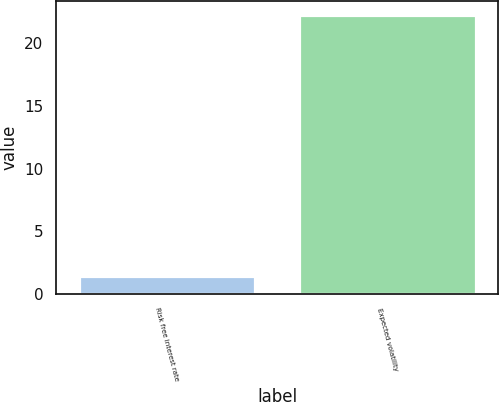Convert chart to OTSL. <chart><loc_0><loc_0><loc_500><loc_500><bar_chart><fcel>Risk free interest rate<fcel>Expected volatility<nl><fcel>1.44<fcel>22.3<nl></chart> 